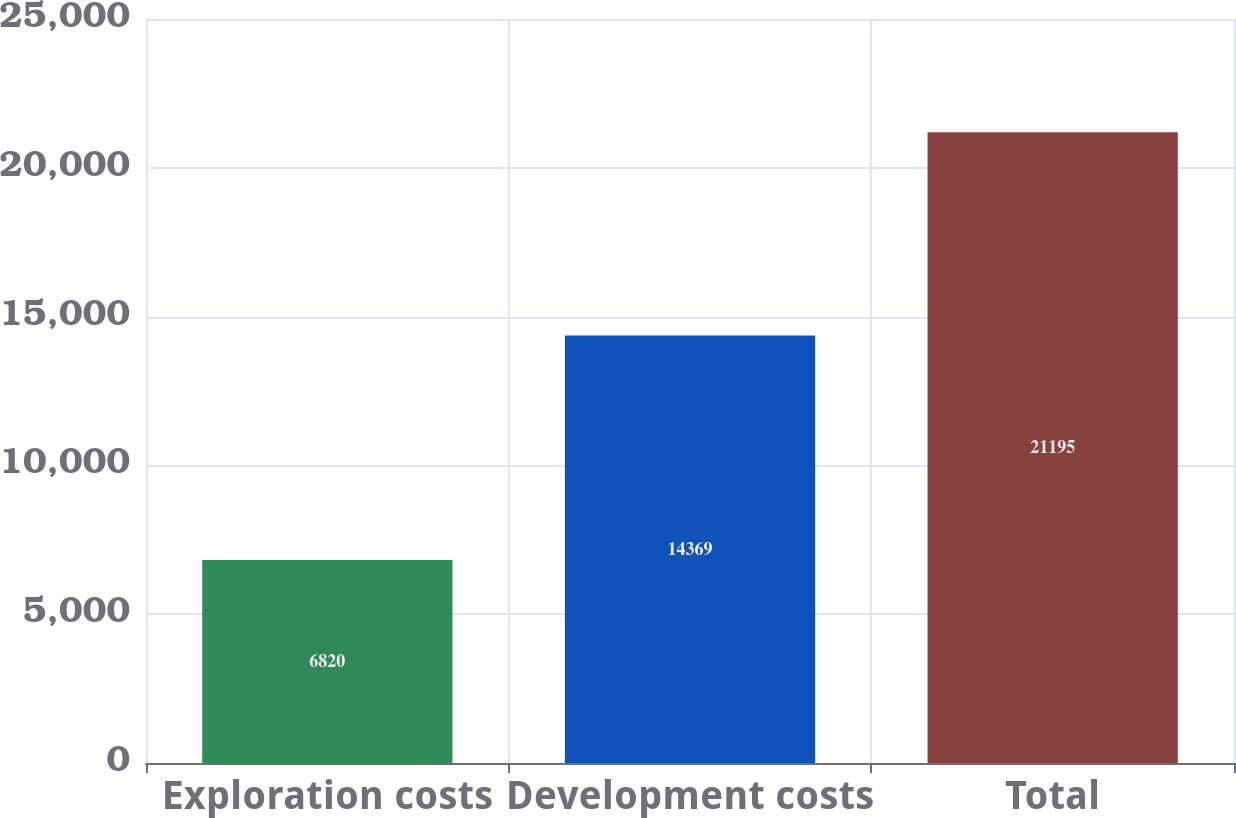Convert chart. <chart><loc_0><loc_0><loc_500><loc_500><bar_chart><fcel>Exploration costs<fcel>Development costs<fcel>Total<nl><fcel>6820<fcel>14369<fcel>21195<nl></chart> 